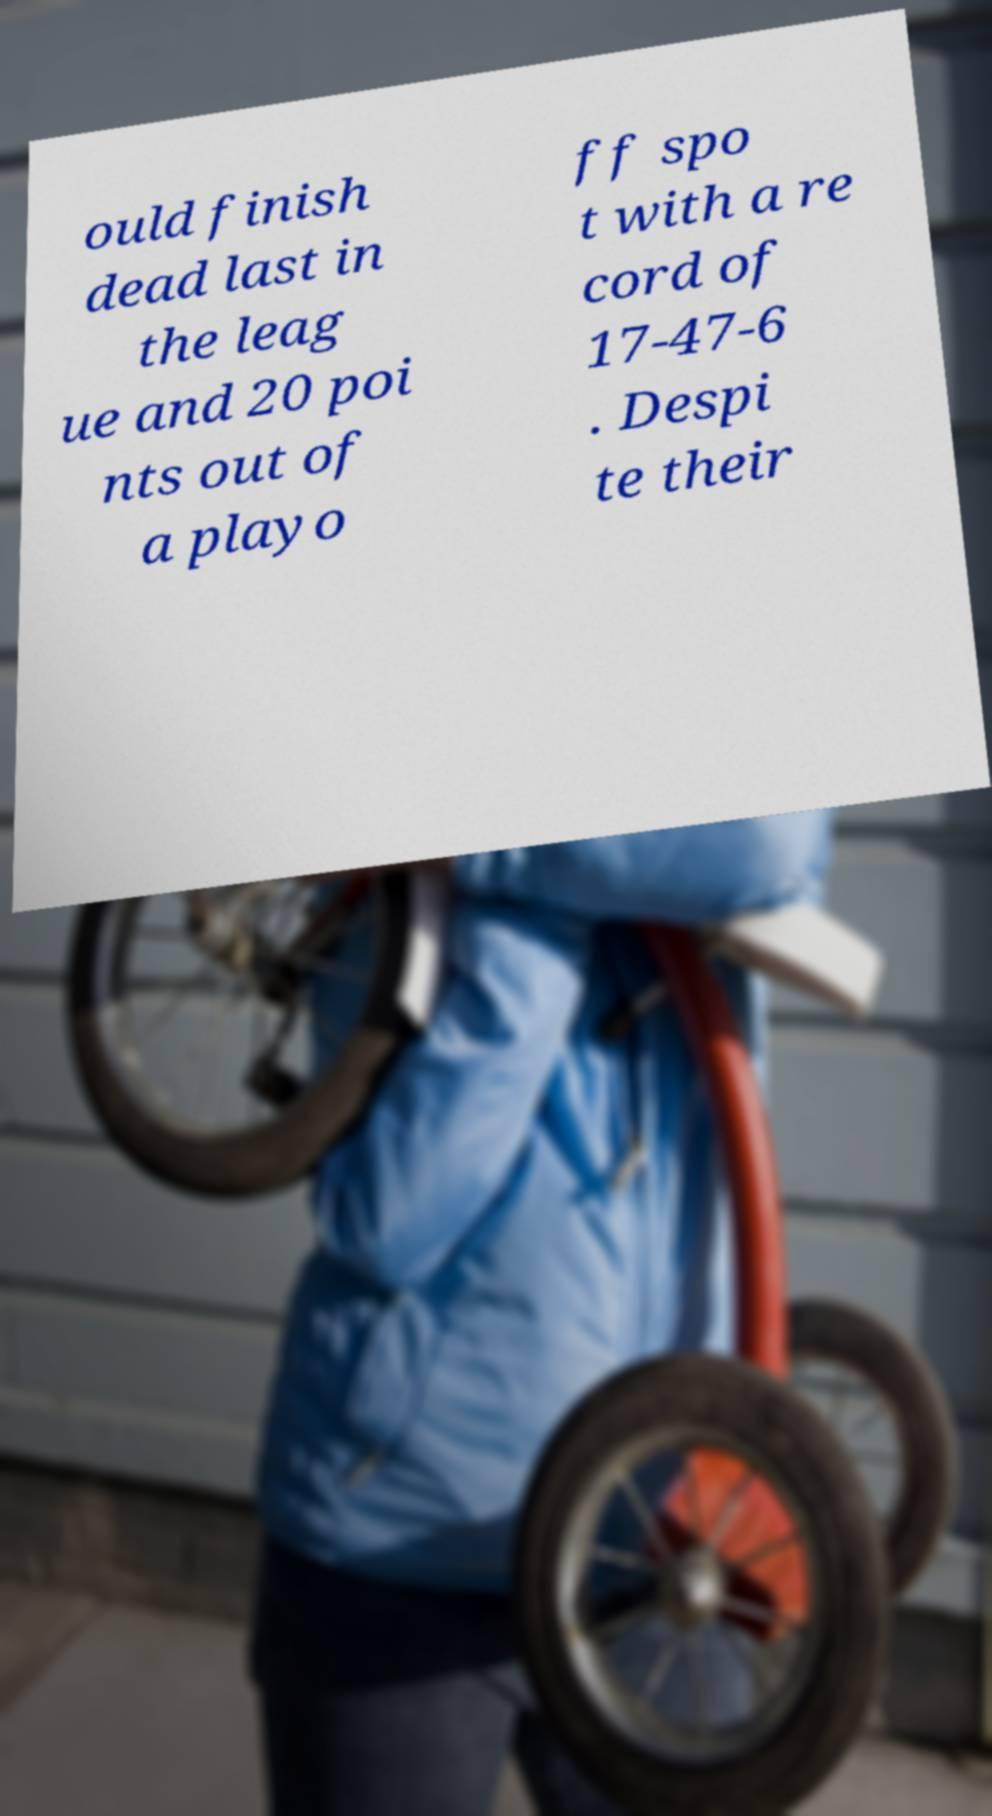Can you accurately transcribe the text from the provided image for me? ould finish dead last in the leag ue and 20 poi nts out of a playo ff spo t with a re cord of 17-47-6 . Despi te their 